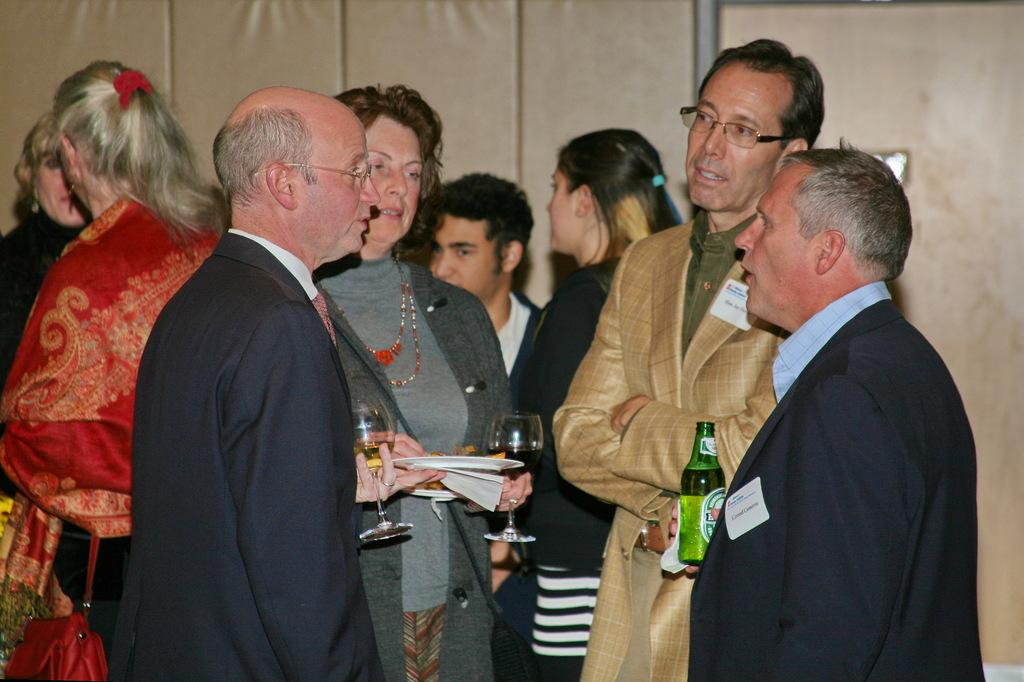What is happening in the image involving the groups of people? The people in the image are standing and talking to each other. What objects are some people holding in the image? Some people are holding wine glasses, plates, and a bottle. Can you describe the setting of the image? There appears to be a wall in the image. What type of mountain can be seen in the background of the image? There is no mountain visible in the image. How many arches are present in the image? There are no arches present in the image. 